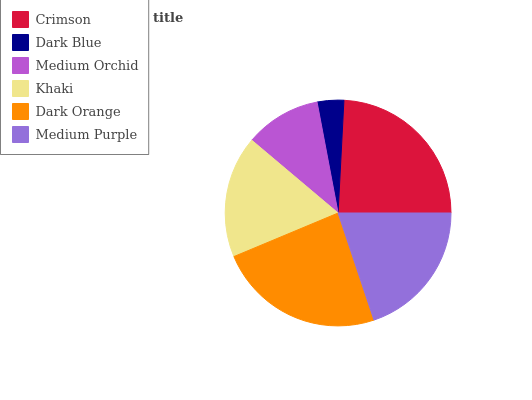Is Dark Blue the minimum?
Answer yes or no. Yes. Is Crimson the maximum?
Answer yes or no. Yes. Is Medium Orchid the minimum?
Answer yes or no. No. Is Medium Orchid the maximum?
Answer yes or no. No. Is Medium Orchid greater than Dark Blue?
Answer yes or no. Yes. Is Dark Blue less than Medium Orchid?
Answer yes or no. Yes. Is Dark Blue greater than Medium Orchid?
Answer yes or no. No. Is Medium Orchid less than Dark Blue?
Answer yes or no. No. Is Medium Purple the high median?
Answer yes or no. Yes. Is Khaki the low median?
Answer yes or no. Yes. Is Crimson the high median?
Answer yes or no. No. Is Medium Purple the low median?
Answer yes or no. No. 